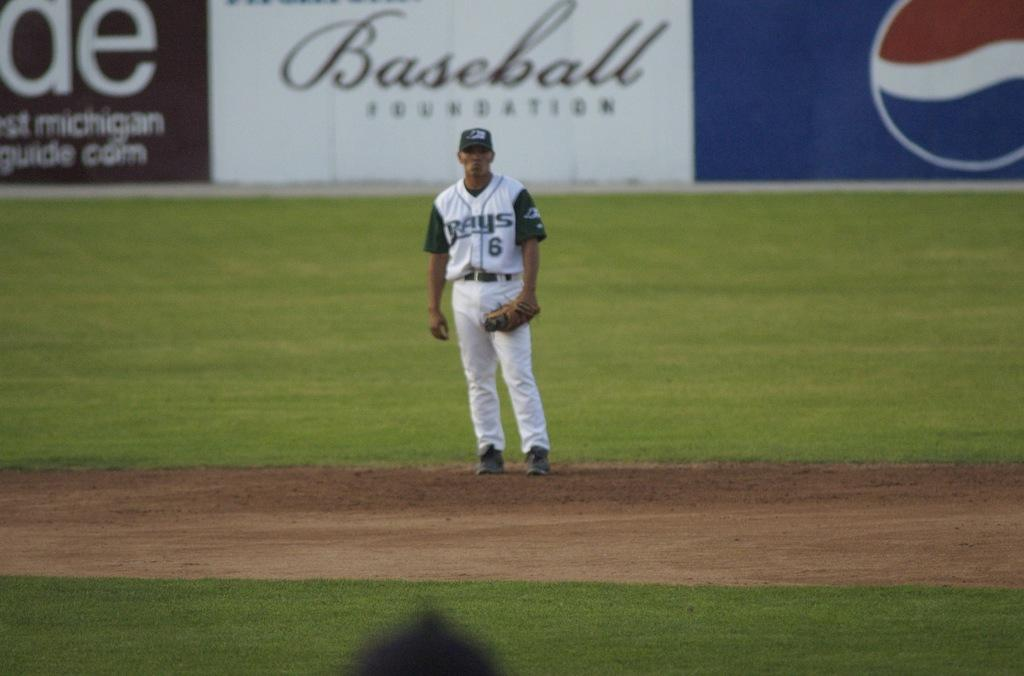Provide a one-sentence caption for the provided image. a baseball player from the rays standing on the field. 